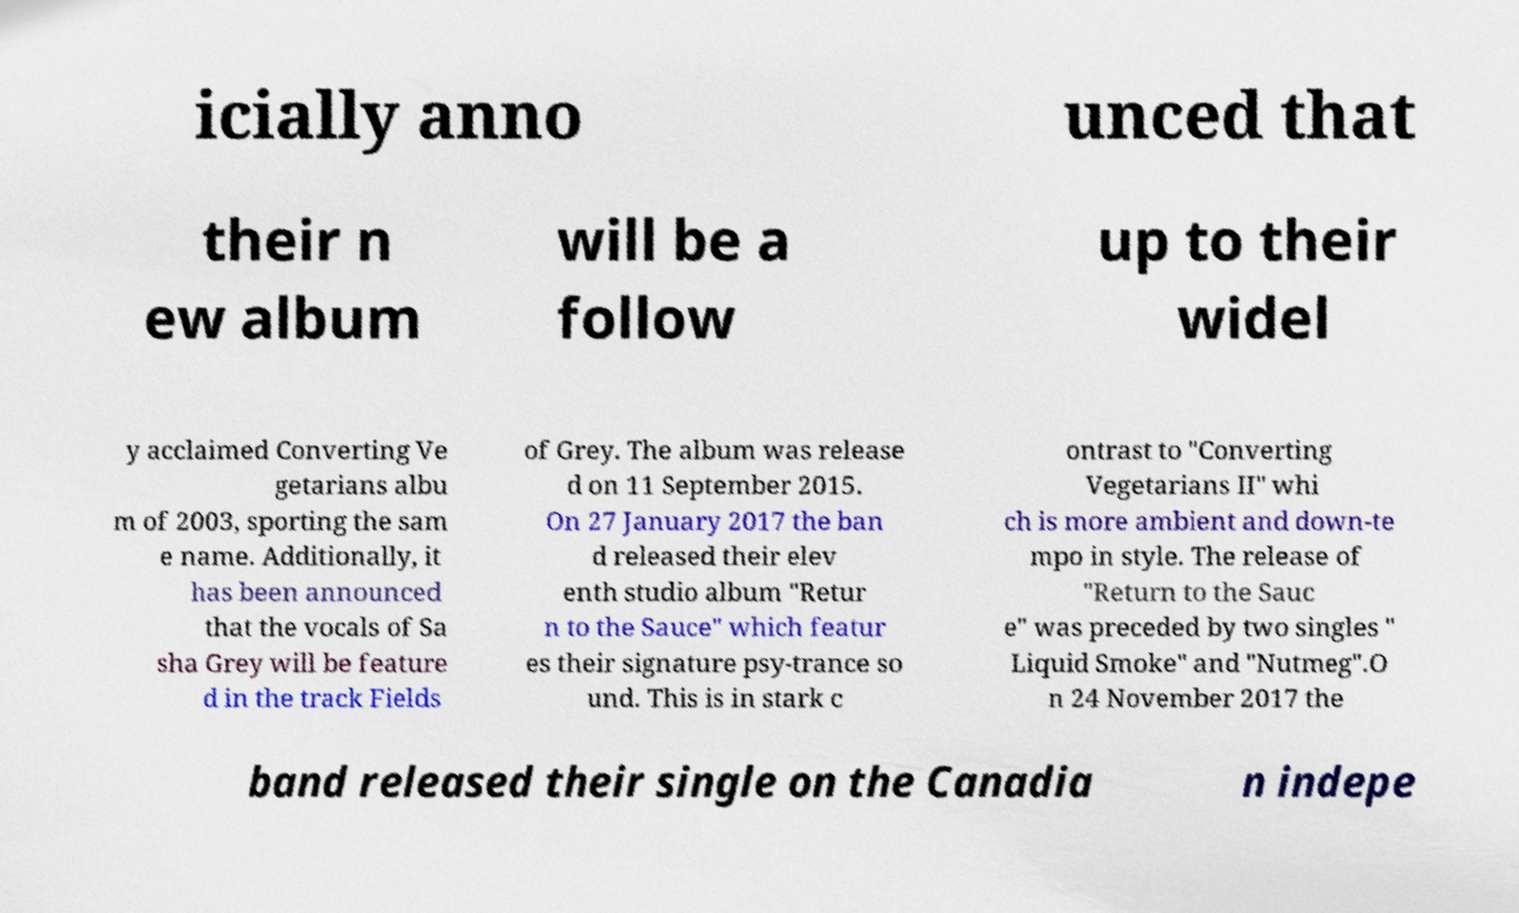Can you accurately transcribe the text from the provided image for me? icially anno unced that their n ew album will be a follow up to their widel y acclaimed Converting Ve getarians albu m of 2003, sporting the sam e name. Additionally, it has been announced that the vocals of Sa sha Grey will be feature d in the track Fields of Grey. The album was release d on 11 September 2015. On 27 January 2017 the ban d released their elev enth studio album "Retur n to the Sauce" which featur es their signature psy-trance so und. This is in stark c ontrast to "Converting Vegetarians II" whi ch is more ambient and down-te mpo in style. The release of "Return to the Sauc e" was preceded by two singles " Liquid Smoke" and "Nutmeg".O n 24 November 2017 the band released their single on the Canadia n indepe 